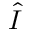Convert formula to latex. <formula><loc_0><loc_0><loc_500><loc_500>\hat { I }</formula> 